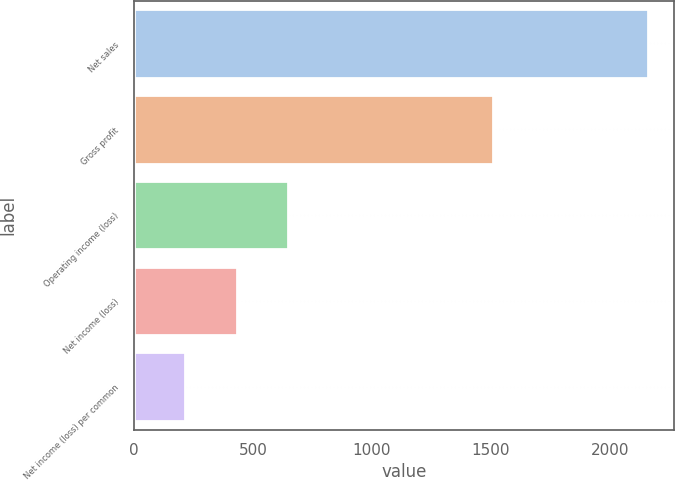Convert chart. <chart><loc_0><loc_0><loc_500><loc_500><bar_chart><fcel>Net sales<fcel>Gross profit<fcel>Operating income (loss)<fcel>Net income (loss)<fcel>Net income (loss) per common<nl><fcel>2160<fcel>1510<fcel>648.15<fcel>432.17<fcel>216.19<nl></chart> 